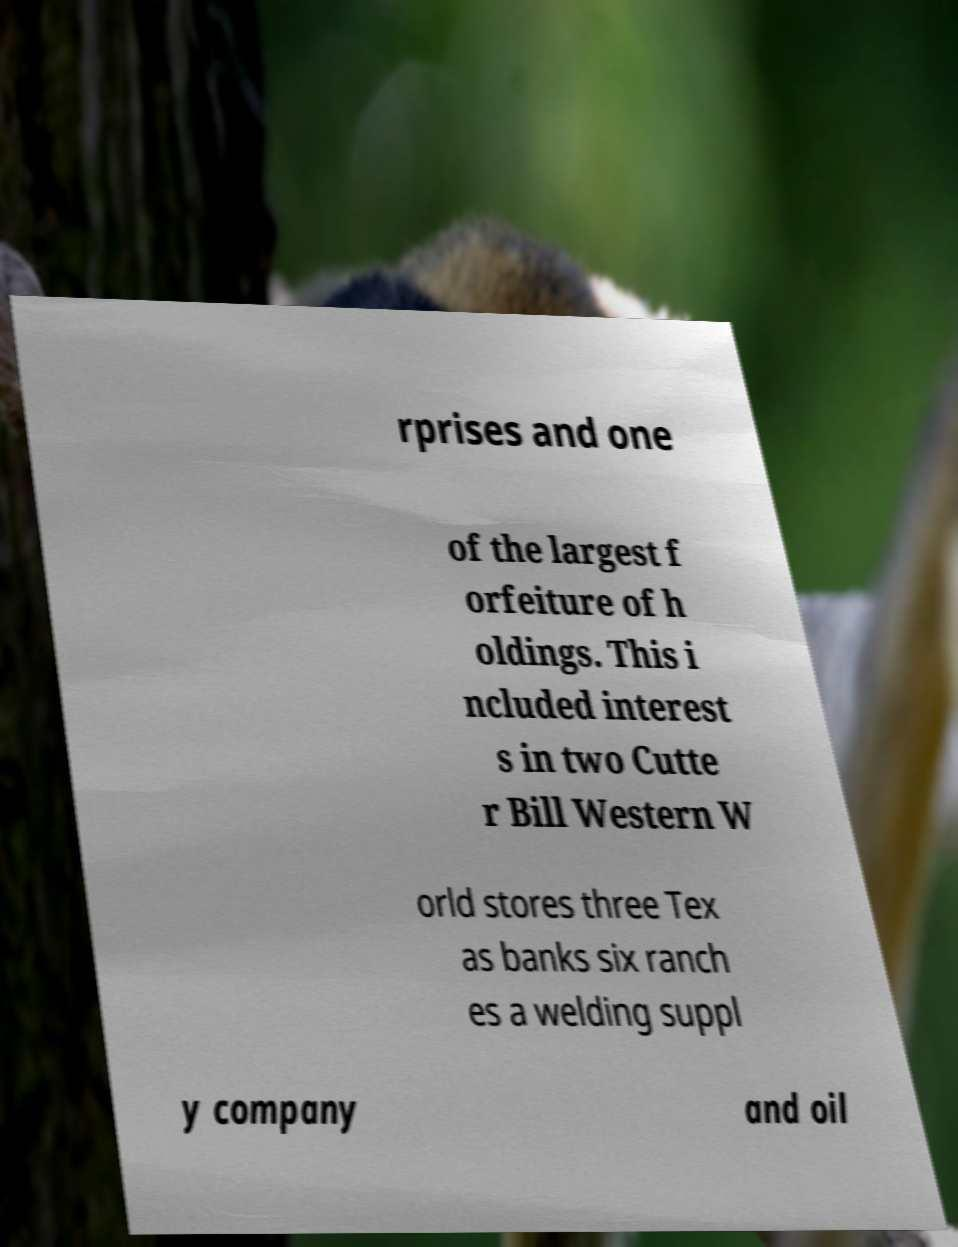There's text embedded in this image that I need extracted. Can you transcribe it verbatim? rprises and one of the largest f orfeiture of h oldings. This i ncluded interest s in two Cutte r Bill Western W orld stores three Tex as banks six ranch es a welding suppl y company and oil 